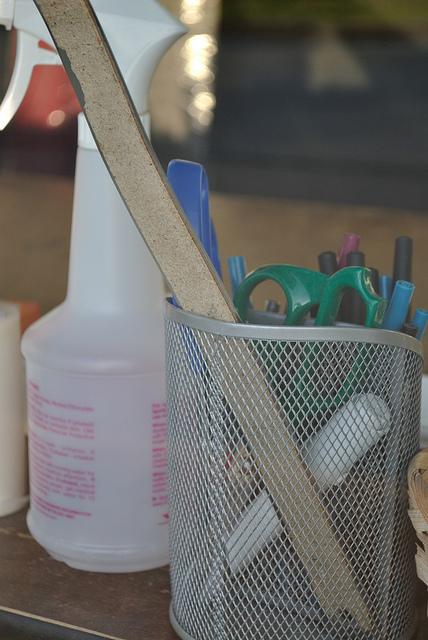Right or left handed scissors?
Quick response, please. Right. What color are the scissor handles?
Concise answer only. Green. What is written on the container?
Write a very short answer. Directions. What color are the scissors?
Write a very short answer. Green. Is that an expensive pen?
Keep it brief. No. What is the plastic bottle to the left of the basket?
Answer briefly. Cleaner. Is there more than one pen in the basket?
Short answer required. Yes. What do you call this machine?
Answer briefly. Ruler. What type of beverage was in the bottle in the back?
Answer briefly. Water. What is in the basket?
Give a very brief answer. Office supplies. 